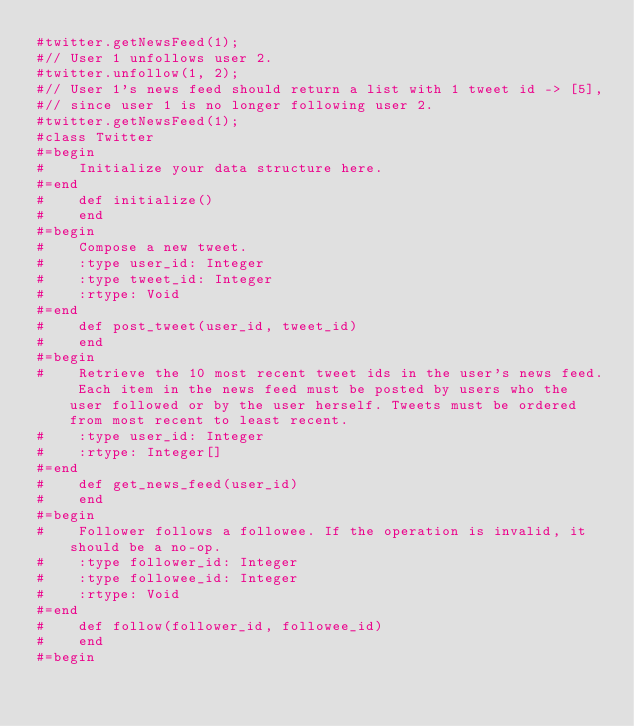<code> <loc_0><loc_0><loc_500><loc_500><_Ruby_>#twitter.getNewsFeed(1);
#// User 1 unfollows user 2.
#twitter.unfollow(1, 2);
#// User 1's news feed should return a list with 1 tweet id -> [5],
#// since user 1 is no longer following user 2.
#twitter.getNewsFeed(1);
#class Twitter
#=begin
#    Initialize your data structure here.
#=end
#    def initialize()
#    end
#=begin
#    Compose a new tweet.
#    :type user_id: Integer
#    :type tweet_id: Integer
#    :rtype: Void
#=end
#    def post_tweet(user_id, tweet_id)
#    end
#=begin
#    Retrieve the 10 most recent tweet ids in the user's news feed. Each item in the news feed must be posted by users who the user followed or by the user herself. Tweets must be ordered from most recent to least recent.
#    :type user_id: Integer
#    :rtype: Integer[]
#=end
#    def get_news_feed(user_id)
#    end
#=begin
#    Follower follows a followee. If the operation is invalid, it should be a no-op.
#    :type follower_id: Integer
#    :type followee_id: Integer
#    :rtype: Void
#=end
#    def follow(follower_id, followee_id)
#    end
#=begin</code> 